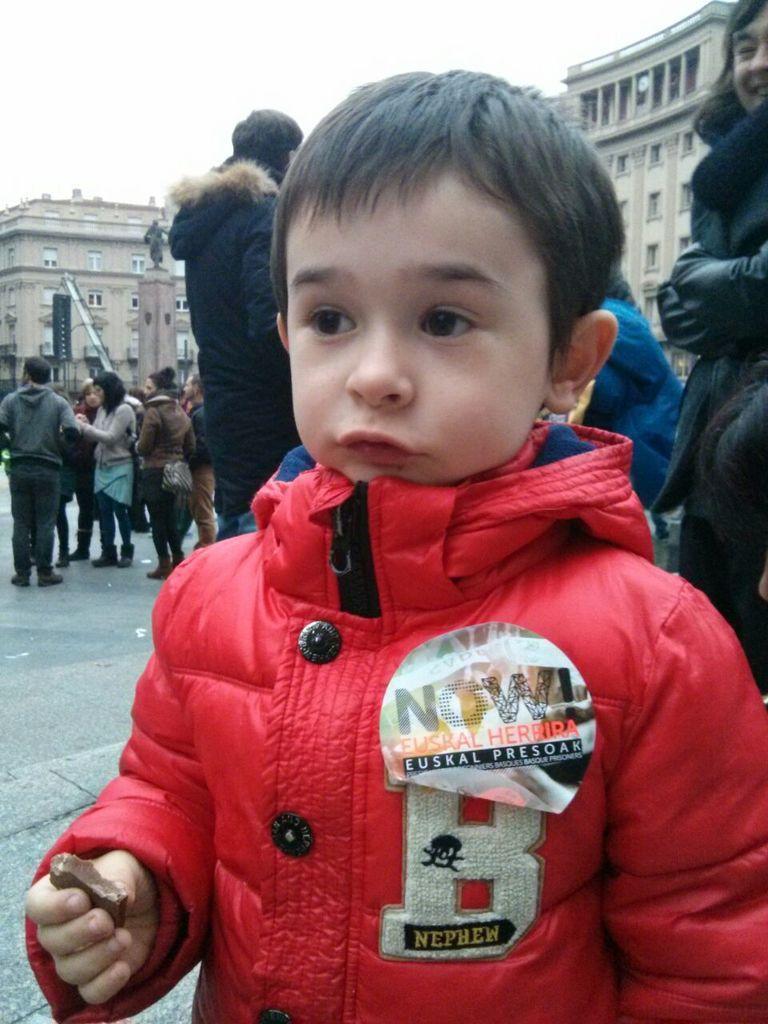Can you describe this image briefly? As we can see in the image there are group of people, buildings, windows and at the top there is sky. The boy standing in the front is wearing red color jacket. 